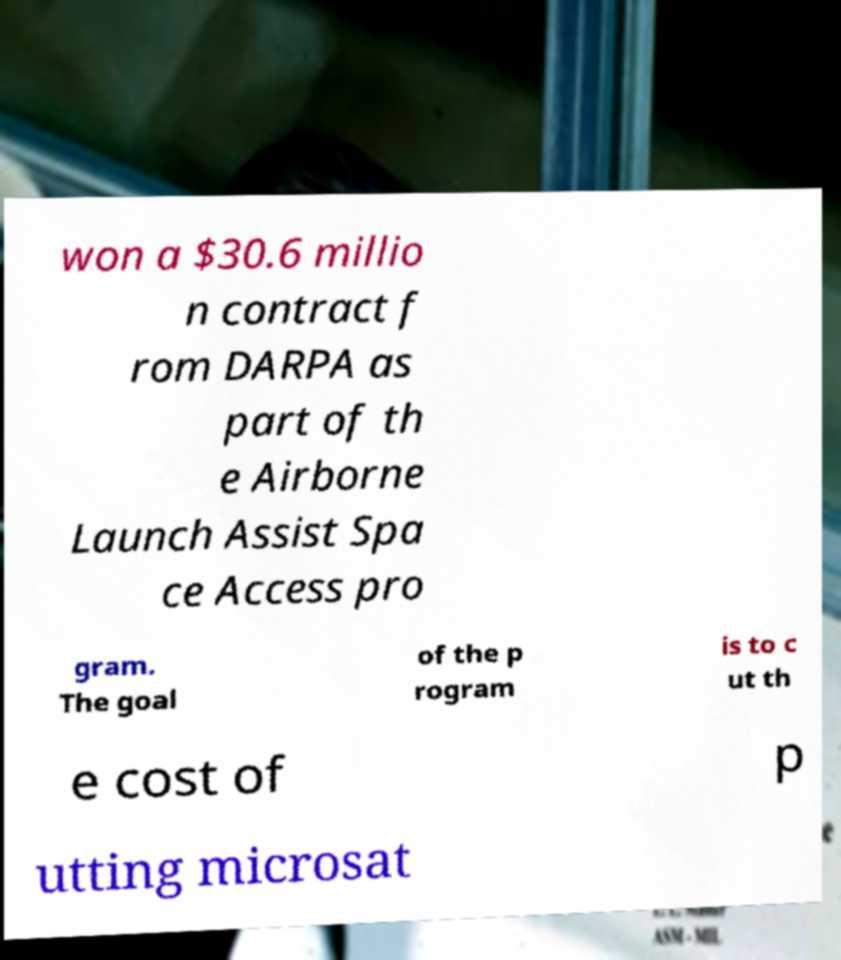What messages or text are displayed in this image? I need them in a readable, typed format. won a $30.6 millio n contract f rom DARPA as part of th e Airborne Launch Assist Spa ce Access pro gram. The goal of the p rogram is to c ut th e cost of p utting microsat 